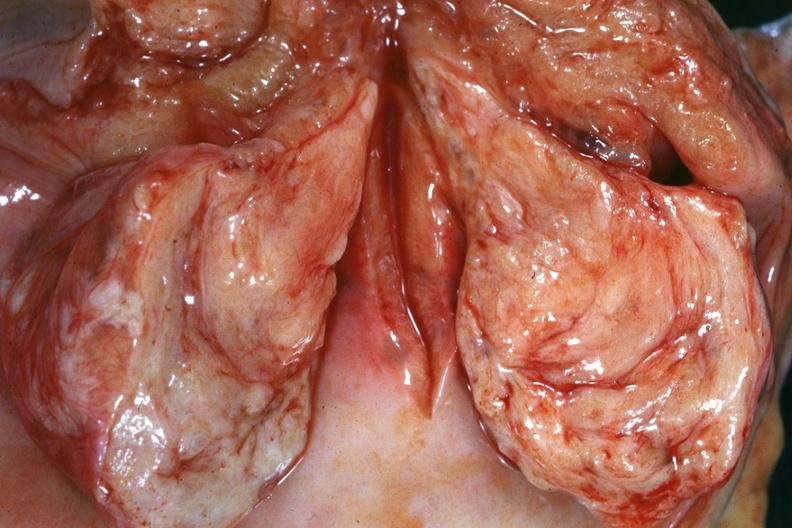what is present?
Answer the question using a single word or phrase. Female reproductive 